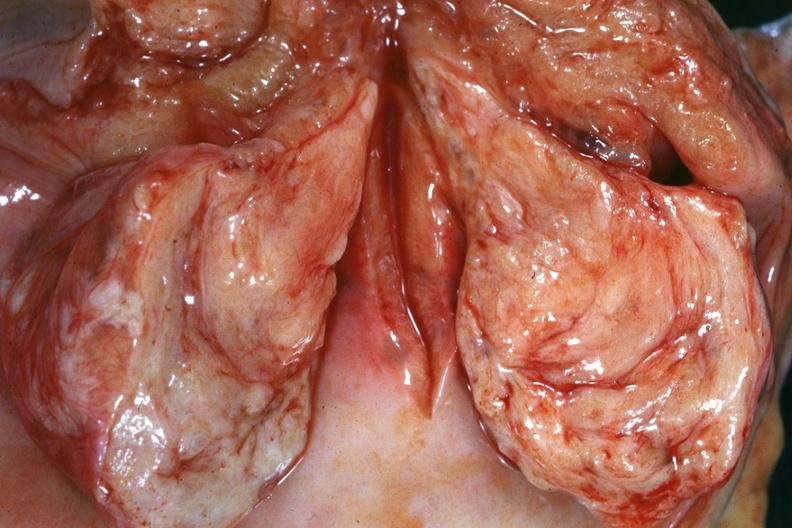what is present?
Answer the question using a single word or phrase. Female reproductive 